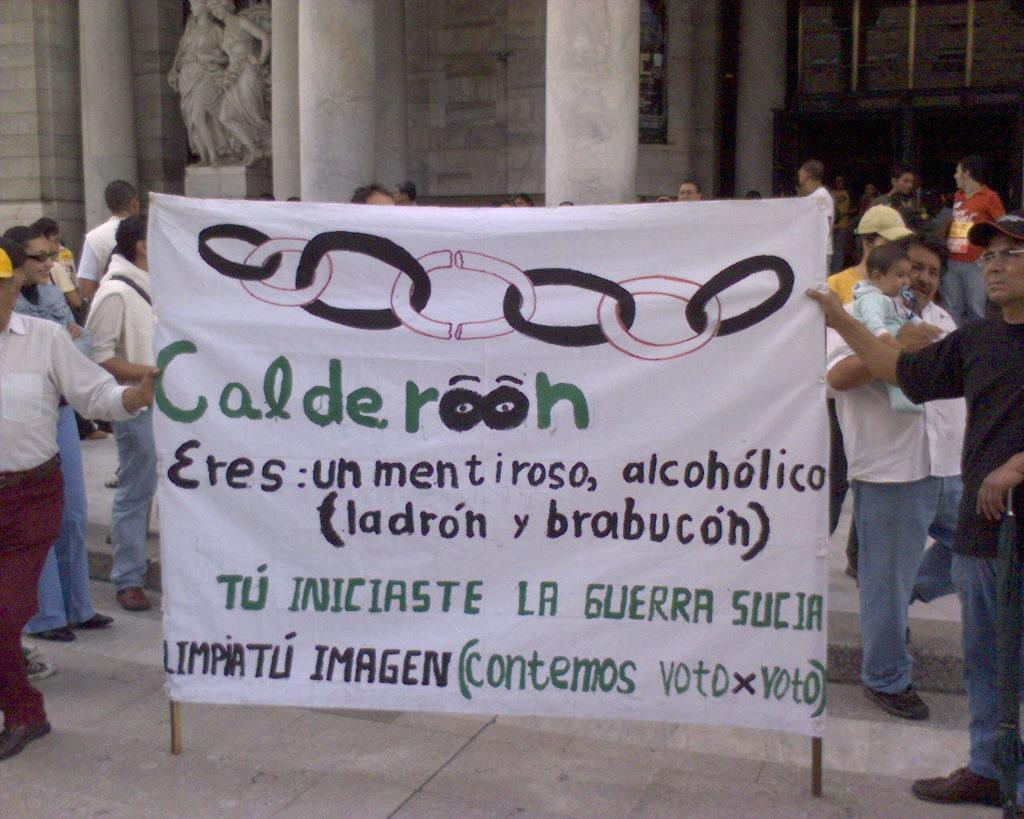How many people are in the image? There are people in the image, but the exact number is not specified. What are two people doing in the image? Two people are holding a banner in the image. What can be seen in the background of the image? In the background of the image, there are pillars, a wall, a banner, and a sculpture. Can you describe the setting of the image? The image appears to be set in a location with pillars, a wall, and a sculpture in the background. What type of play is happening in the image? There is no mention of a play or any related activities in the image. 